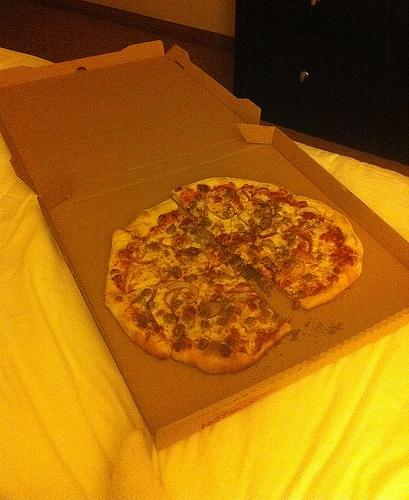What object is located near the pizza box, and what color is it? A foot with a sock on it is located near the pizza box, having shades of gray and white. Mention an interesting feature you observe on the pizza crust. There are burnt spots on the pizza crust. How would you describe the surface the pizza box is placed upon? The surface under the pizza box is a yellow cloth with creases, located on a bed. Enumerate the different alternatives used to describe the pizza in the given captions. hot, good, delicious, flavorful, tasty, great, well seasoned, and chunky-cheesy. How many slices of pizza can be seen in the box? There are eight slices of pizza in the box. What is the color of the furniture against the wall? The furniture against the wall is black. Provide a brief description of the pizza in the image. The pizza in the image is a large, round, half-and-half pizza with various toppings, such as mushrooms, sausage, and cheese, placed inside a cardboard box. What type of box is the pizza placed in, and what is the condition of this box? The pizza is placed in a brown cardboard box, with grease stains visible on it. In a playful way, describe what the mushrooms on the pizza might be thinking. "These are some seriously yummy surroundings! Glad we found our cheesy home!" Compose a haiku about the pizza in the image. Half-and-half delight. How many slices of pizza can you see in this box? Two halves, making 1 whole pizza. Analyze the interaction between the pizza box and the surface it's on. The pizza box is placed on a yellow surface, grease stains are visible on the cardboard box. Can you find any instances of text in the image? No, there is no text in the image. How does the pizza in the box appear to be seasoned? Well seasoned. Look at the picture frame on the wall, it contains a beautiful landscape painting.  This instruction is misleading because there is no record of a picture frame or a painting in the image's information. It inaccurately suggests that the room is decorated with artwork, which is not the case. Is there a cat lying on the yellow surface under the pizza box? No, it's not mentioned in the image. What captions refer to the pizza box? cardboard box pizza is in, this is a cardboard box, the box is brown. Are any objects in the image interacting with one another? Yes, the pizza slices are inside the box. What is the condition of the pizza's crust? The crust is thin. Would you consider this pizza to look appetizing based on the image? Yes, the pizza appears to be appetizing. Identify the objects on the flooring. Foot with sock, pizza box with pizza inside. Is the pizza in a cardboard box or on a plate? The pizza is in a cardboard box. Choose the best answer: what's on the pizza? A) mushrooms, B) pineapple, C) chocolate A) mushrooms What is the main subject of this image? A hot, well-seasoned pizza in a cardboard box. What color is the piece of furniture against the wall? The furniture is black. Can you see the toppings on the pizza? Yes, toppings such as mushrooms and sausage are visible. Evaluate the quality of the image. The image is of high quality and clear. Notice the blue curtains on the window, aren't they pretty?  This instruction is misleading because there is no mention of a window or blue curtains in the image's information. It creates a false visual element by suggesting something that is not present in the image. What attributes are observed on the pizza? The pizza is hot, seasoned, cheesy, sliced, and has toppings like mushrooms and sausage. Are there any unusual or unexpected objects in the image? No, all objects appear normal. What emotion do you feel looking at the image? Hungry or craving pizza. Describe the main components within the image. There is a black dresser, a hot pizza in a box on a yellow surface, and a foot with sock on it. Can you see the television set in front of the dark-colored flooring? It's showing a popular movie. There is a mention of dark-colored flooring in the image, but there's no information about a television set or anything related to it. This instruction creates a false scenario by adding non-existent elements to the scene. 